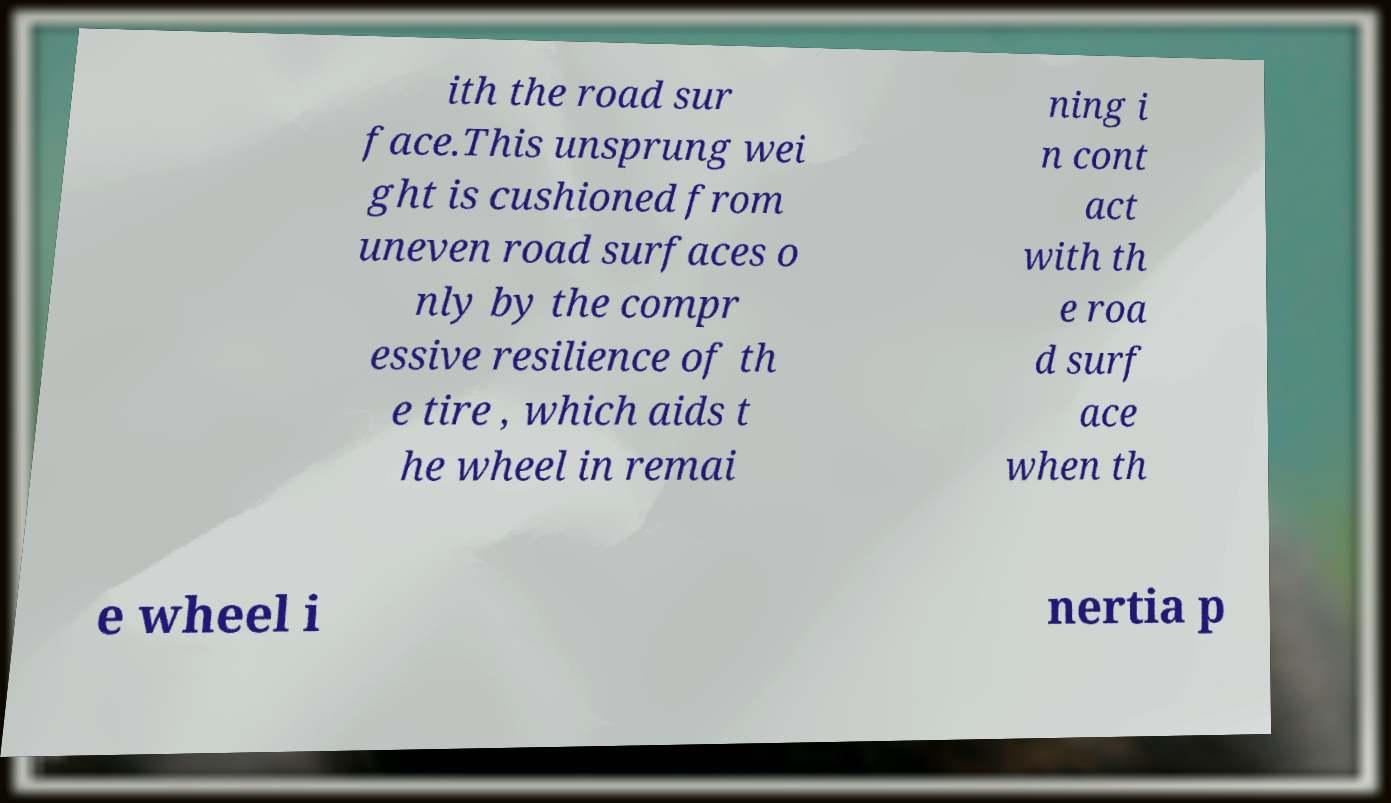I need the written content from this picture converted into text. Can you do that? ith the road sur face.This unsprung wei ght is cushioned from uneven road surfaces o nly by the compr essive resilience of th e tire , which aids t he wheel in remai ning i n cont act with th e roa d surf ace when th e wheel i nertia p 